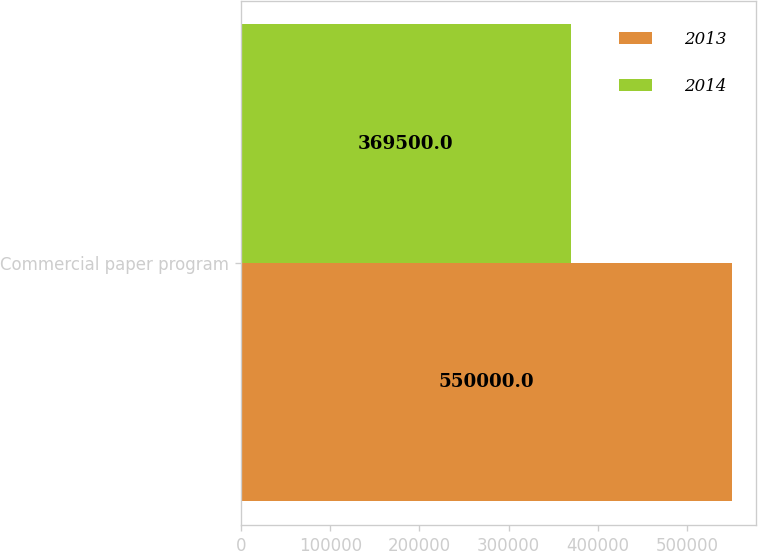Convert chart to OTSL. <chart><loc_0><loc_0><loc_500><loc_500><stacked_bar_chart><ecel><fcel>Commercial paper program<nl><fcel>2013<fcel>550000<nl><fcel>2014<fcel>369500<nl></chart> 